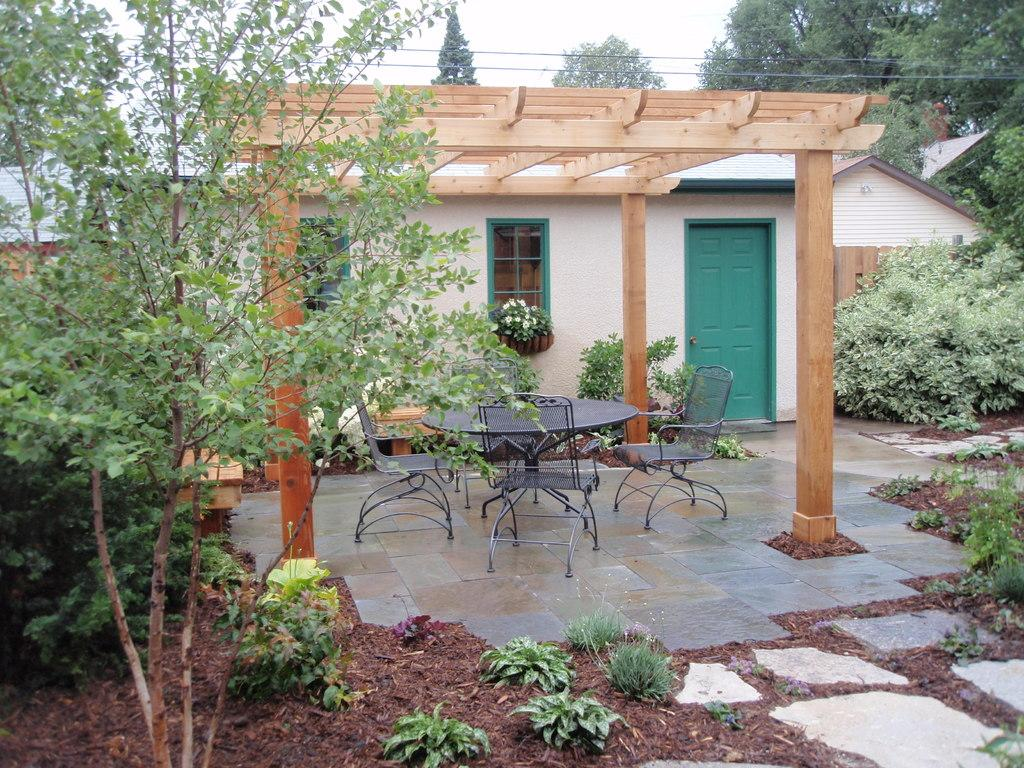What type of structure is present in the picture? There is a house in the picture. What type of furniture can be seen in the picture? There are chairs in the picture. What type of vegetation is present in the picture? There are plants and trees in the picture. What type of surface is present in the picture? There is a table in the picture. What type of utility is present in the picture? There are cables in the picture. What is visible in the background of the picture? The sky is visible in the background of the picture. Can you tell me how many flowers are in the garden in the image? There is no garden present in the image, so it is not possible to determine the number of flowers. What type of celestial body is visible in the image? The sky is visible in the background of the picture, but there is no mention of any celestial bodies such as the moon. 